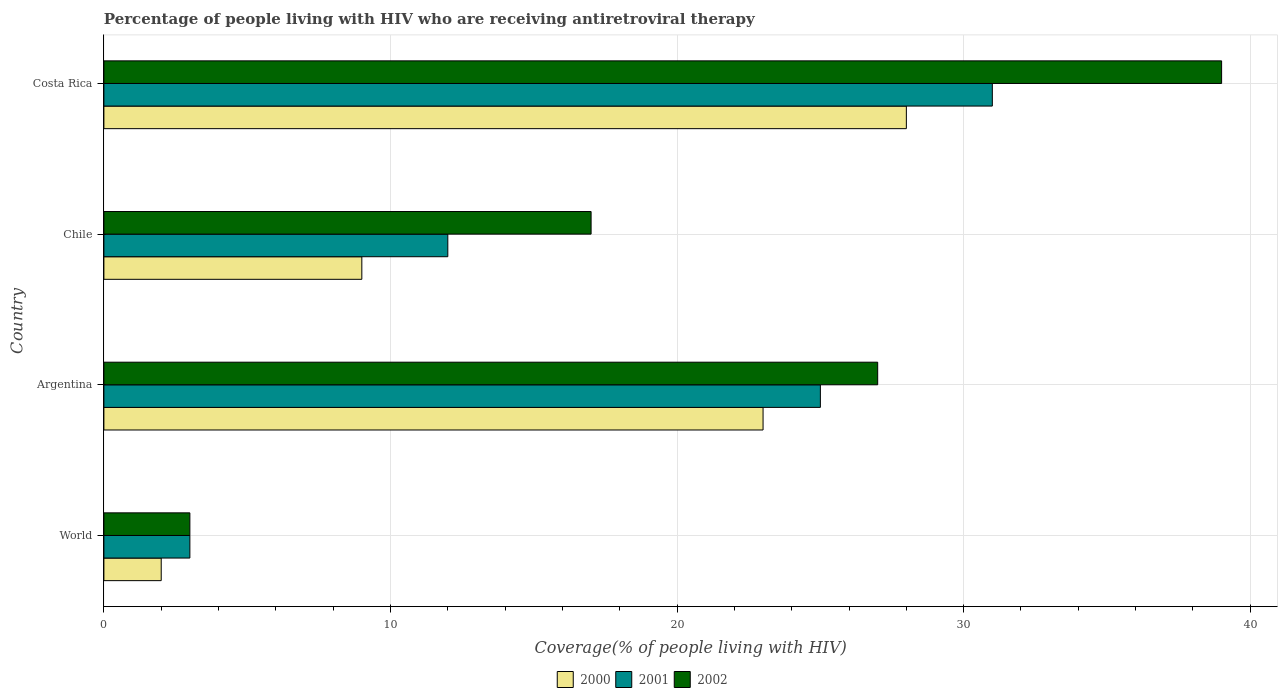How many groups of bars are there?
Your answer should be compact. 4. Are the number of bars per tick equal to the number of legend labels?
Your answer should be very brief. Yes. How many bars are there on the 1st tick from the bottom?
Make the answer very short. 3. What is the label of the 4th group of bars from the top?
Ensure brevity in your answer.  World. In how many cases, is the number of bars for a given country not equal to the number of legend labels?
Your response must be concise. 0. What is the percentage of the HIV infected people who are receiving antiretroviral therapy in 2001 in Costa Rica?
Offer a terse response. 31. Across all countries, what is the maximum percentage of the HIV infected people who are receiving antiretroviral therapy in 2001?
Give a very brief answer. 31. Across all countries, what is the minimum percentage of the HIV infected people who are receiving antiretroviral therapy in 2000?
Keep it short and to the point. 2. In which country was the percentage of the HIV infected people who are receiving antiretroviral therapy in 2000 maximum?
Provide a short and direct response. Costa Rica. In which country was the percentage of the HIV infected people who are receiving antiretroviral therapy in 2002 minimum?
Offer a terse response. World. What is the total percentage of the HIV infected people who are receiving antiretroviral therapy in 2002 in the graph?
Offer a very short reply. 86. What is the difference between the percentage of the HIV infected people who are receiving antiretroviral therapy in 2001 in Chile and that in World?
Give a very brief answer. 9. What is the difference between the percentage of the HIV infected people who are receiving antiretroviral therapy in 2002 in Costa Rica and the percentage of the HIV infected people who are receiving antiretroviral therapy in 2000 in World?
Give a very brief answer. 37. What is the average percentage of the HIV infected people who are receiving antiretroviral therapy in 2000 per country?
Offer a terse response. 15.5. What is the difference between the percentage of the HIV infected people who are receiving antiretroviral therapy in 2002 and percentage of the HIV infected people who are receiving antiretroviral therapy in 2001 in Argentina?
Your answer should be very brief. 2. In how many countries, is the percentage of the HIV infected people who are receiving antiretroviral therapy in 2001 greater than 8 %?
Give a very brief answer. 3. Is the difference between the percentage of the HIV infected people who are receiving antiretroviral therapy in 2002 in Argentina and Costa Rica greater than the difference between the percentage of the HIV infected people who are receiving antiretroviral therapy in 2001 in Argentina and Costa Rica?
Your answer should be compact. No. What is the difference between the highest and the lowest percentage of the HIV infected people who are receiving antiretroviral therapy in 2002?
Offer a terse response. 36. In how many countries, is the percentage of the HIV infected people who are receiving antiretroviral therapy in 2002 greater than the average percentage of the HIV infected people who are receiving antiretroviral therapy in 2002 taken over all countries?
Your response must be concise. 2. What does the 3rd bar from the top in Costa Rica represents?
Offer a very short reply. 2000. What does the 1st bar from the bottom in Argentina represents?
Offer a terse response. 2000. Are all the bars in the graph horizontal?
Give a very brief answer. Yes. Are the values on the major ticks of X-axis written in scientific E-notation?
Provide a short and direct response. No. Does the graph contain any zero values?
Your response must be concise. No. Where does the legend appear in the graph?
Offer a very short reply. Bottom center. What is the title of the graph?
Offer a very short reply. Percentage of people living with HIV who are receiving antiretroviral therapy. What is the label or title of the X-axis?
Give a very brief answer. Coverage(% of people living with HIV). What is the Coverage(% of people living with HIV) of 2001 in World?
Keep it short and to the point. 3. What is the Coverage(% of people living with HIV) of 2002 in World?
Your answer should be very brief. 3. What is the Coverage(% of people living with HIV) in 2000 in Argentina?
Ensure brevity in your answer.  23. What is the Coverage(% of people living with HIV) in 2001 in Argentina?
Your answer should be compact. 25. What is the Coverage(% of people living with HIV) of 2000 in Chile?
Your answer should be compact. 9. What is the Coverage(% of people living with HIV) in 2001 in Chile?
Keep it short and to the point. 12. What is the Coverage(% of people living with HIV) of 2002 in Chile?
Offer a terse response. 17. What is the Coverage(% of people living with HIV) in 2001 in Costa Rica?
Give a very brief answer. 31. Across all countries, what is the minimum Coverage(% of people living with HIV) of 2002?
Ensure brevity in your answer.  3. What is the total Coverage(% of people living with HIV) of 2000 in the graph?
Give a very brief answer. 62. What is the total Coverage(% of people living with HIV) of 2001 in the graph?
Give a very brief answer. 71. What is the difference between the Coverage(% of people living with HIV) in 2000 in World and that in Argentina?
Offer a very short reply. -21. What is the difference between the Coverage(% of people living with HIV) in 2000 in World and that in Chile?
Your response must be concise. -7. What is the difference between the Coverage(% of people living with HIV) in 2002 in World and that in Chile?
Your answer should be very brief. -14. What is the difference between the Coverage(% of people living with HIV) of 2000 in World and that in Costa Rica?
Provide a short and direct response. -26. What is the difference between the Coverage(% of people living with HIV) of 2001 in World and that in Costa Rica?
Your answer should be compact. -28. What is the difference between the Coverage(% of people living with HIV) of 2002 in World and that in Costa Rica?
Ensure brevity in your answer.  -36. What is the difference between the Coverage(% of people living with HIV) of 2001 in Argentina and that in Chile?
Keep it short and to the point. 13. What is the difference between the Coverage(% of people living with HIV) of 2000 in Argentina and that in Costa Rica?
Provide a succinct answer. -5. What is the difference between the Coverage(% of people living with HIV) in 2000 in Chile and that in Costa Rica?
Offer a very short reply. -19. What is the difference between the Coverage(% of people living with HIV) in 2001 in Chile and that in Costa Rica?
Your answer should be very brief. -19. What is the difference between the Coverage(% of people living with HIV) of 2002 in Chile and that in Costa Rica?
Your answer should be very brief. -22. What is the difference between the Coverage(% of people living with HIV) in 2000 in World and the Coverage(% of people living with HIV) in 2001 in Argentina?
Your response must be concise. -23. What is the difference between the Coverage(% of people living with HIV) in 2001 in World and the Coverage(% of people living with HIV) in 2002 in Chile?
Keep it short and to the point. -14. What is the difference between the Coverage(% of people living with HIV) of 2000 in World and the Coverage(% of people living with HIV) of 2001 in Costa Rica?
Ensure brevity in your answer.  -29. What is the difference between the Coverage(% of people living with HIV) of 2000 in World and the Coverage(% of people living with HIV) of 2002 in Costa Rica?
Keep it short and to the point. -37. What is the difference between the Coverage(% of people living with HIV) in 2001 in World and the Coverage(% of people living with HIV) in 2002 in Costa Rica?
Provide a short and direct response. -36. What is the difference between the Coverage(% of people living with HIV) of 2000 in Argentina and the Coverage(% of people living with HIV) of 2002 in Chile?
Your answer should be very brief. 6. What is the difference between the Coverage(% of people living with HIV) of 2001 in Argentina and the Coverage(% of people living with HIV) of 2002 in Chile?
Give a very brief answer. 8. What is the difference between the Coverage(% of people living with HIV) of 2000 in Argentina and the Coverage(% of people living with HIV) of 2001 in Costa Rica?
Make the answer very short. -8. What is the difference between the Coverage(% of people living with HIV) in 2001 in Argentina and the Coverage(% of people living with HIV) in 2002 in Costa Rica?
Your response must be concise. -14. What is the difference between the Coverage(% of people living with HIV) of 2000 in Chile and the Coverage(% of people living with HIV) of 2001 in Costa Rica?
Offer a terse response. -22. What is the average Coverage(% of people living with HIV) in 2001 per country?
Provide a short and direct response. 17.75. What is the difference between the Coverage(% of people living with HIV) of 2000 and Coverage(% of people living with HIV) of 2001 in World?
Offer a terse response. -1. What is the difference between the Coverage(% of people living with HIV) in 2001 and Coverage(% of people living with HIV) in 2002 in World?
Offer a terse response. 0. What is the difference between the Coverage(% of people living with HIV) of 2000 and Coverage(% of people living with HIV) of 2001 in Chile?
Offer a terse response. -3. What is the difference between the Coverage(% of people living with HIV) of 2000 and Coverage(% of people living with HIV) of 2002 in Chile?
Ensure brevity in your answer.  -8. What is the difference between the Coverage(% of people living with HIV) in 2000 and Coverage(% of people living with HIV) in 2001 in Costa Rica?
Provide a short and direct response. -3. What is the difference between the Coverage(% of people living with HIV) in 2000 and Coverage(% of people living with HIV) in 2002 in Costa Rica?
Make the answer very short. -11. What is the difference between the Coverage(% of people living with HIV) of 2001 and Coverage(% of people living with HIV) of 2002 in Costa Rica?
Make the answer very short. -8. What is the ratio of the Coverage(% of people living with HIV) of 2000 in World to that in Argentina?
Your answer should be compact. 0.09. What is the ratio of the Coverage(% of people living with HIV) in 2001 in World to that in Argentina?
Your answer should be very brief. 0.12. What is the ratio of the Coverage(% of people living with HIV) of 2002 in World to that in Argentina?
Give a very brief answer. 0.11. What is the ratio of the Coverage(% of people living with HIV) of 2000 in World to that in Chile?
Make the answer very short. 0.22. What is the ratio of the Coverage(% of people living with HIV) in 2002 in World to that in Chile?
Your answer should be compact. 0.18. What is the ratio of the Coverage(% of people living with HIV) of 2000 in World to that in Costa Rica?
Give a very brief answer. 0.07. What is the ratio of the Coverage(% of people living with HIV) of 2001 in World to that in Costa Rica?
Your answer should be compact. 0.1. What is the ratio of the Coverage(% of people living with HIV) in 2002 in World to that in Costa Rica?
Your answer should be very brief. 0.08. What is the ratio of the Coverage(% of people living with HIV) of 2000 in Argentina to that in Chile?
Your response must be concise. 2.56. What is the ratio of the Coverage(% of people living with HIV) of 2001 in Argentina to that in Chile?
Your response must be concise. 2.08. What is the ratio of the Coverage(% of people living with HIV) in 2002 in Argentina to that in Chile?
Your answer should be compact. 1.59. What is the ratio of the Coverage(% of people living with HIV) of 2000 in Argentina to that in Costa Rica?
Your answer should be very brief. 0.82. What is the ratio of the Coverage(% of people living with HIV) in 2001 in Argentina to that in Costa Rica?
Give a very brief answer. 0.81. What is the ratio of the Coverage(% of people living with HIV) of 2002 in Argentina to that in Costa Rica?
Offer a terse response. 0.69. What is the ratio of the Coverage(% of people living with HIV) of 2000 in Chile to that in Costa Rica?
Your answer should be very brief. 0.32. What is the ratio of the Coverage(% of people living with HIV) in 2001 in Chile to that in Costa Rica?
Provide a succinct answer. 0.39. What is the ratio of the Coverage(% of people living with HIV) in 2002 in Chile to that in Costa Rica?
Offer a terse response. 0.44. What is the difference between the highest and the second highest Coverage(% of people living with HIV) in 2000?
Give a very brief answer. 5. What is the difference between the highest and the second highest Coverage(% of people living with HIV) in 2001?
Provide a succinct answer. 6. What is the difference between the highest and the second highest Coverage(% of people living with HIV) of 2002?
Offer a terse response. 12. What is the difference between the highest and the lowest Coverage(% of people living with HIV) in 2000?
Make the answer very short. 26. What is the difference between the highest and the lowest Coverage(% of people living with HIV) in 2001?
Your answer should be compact. 28. What is the difference between the highest and the lowest Coverage(% of people living with HIV) of 2002?
Make the answer very short. 36. 